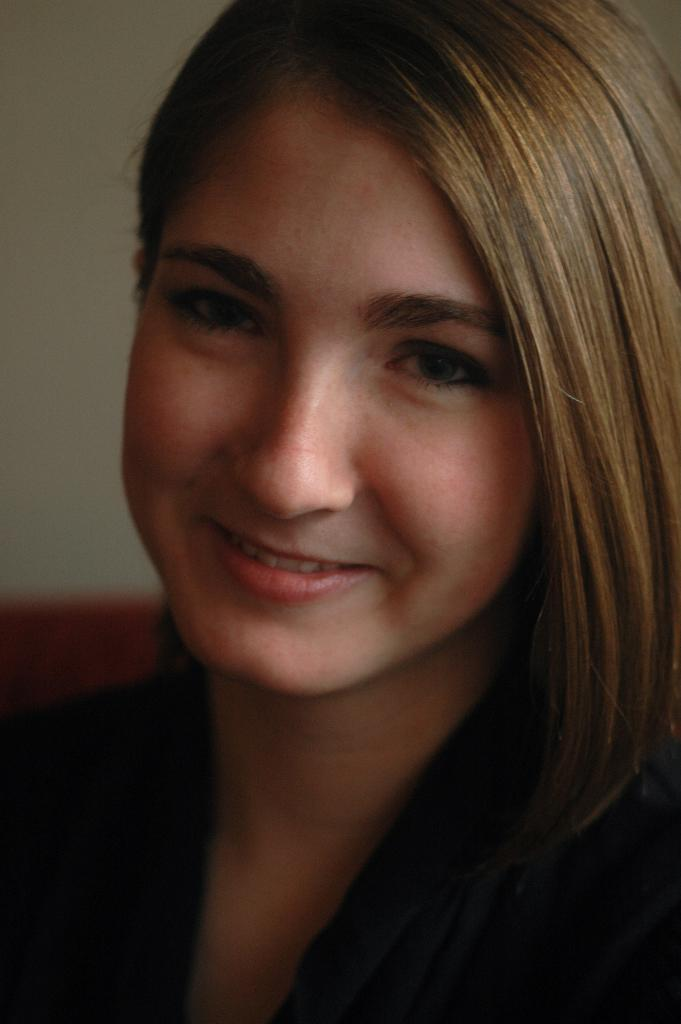Who is present in the image? There is a woman in the image. What expression does the woman have? The woman is smiling. What can be seen in the background of the image? There is a wall in the background of the image. What type of trousers is the ant wearing in the image? There is no ant or trousers present in the image. How many potatoes can be seen in the image? There are no potatoes present in the image. 